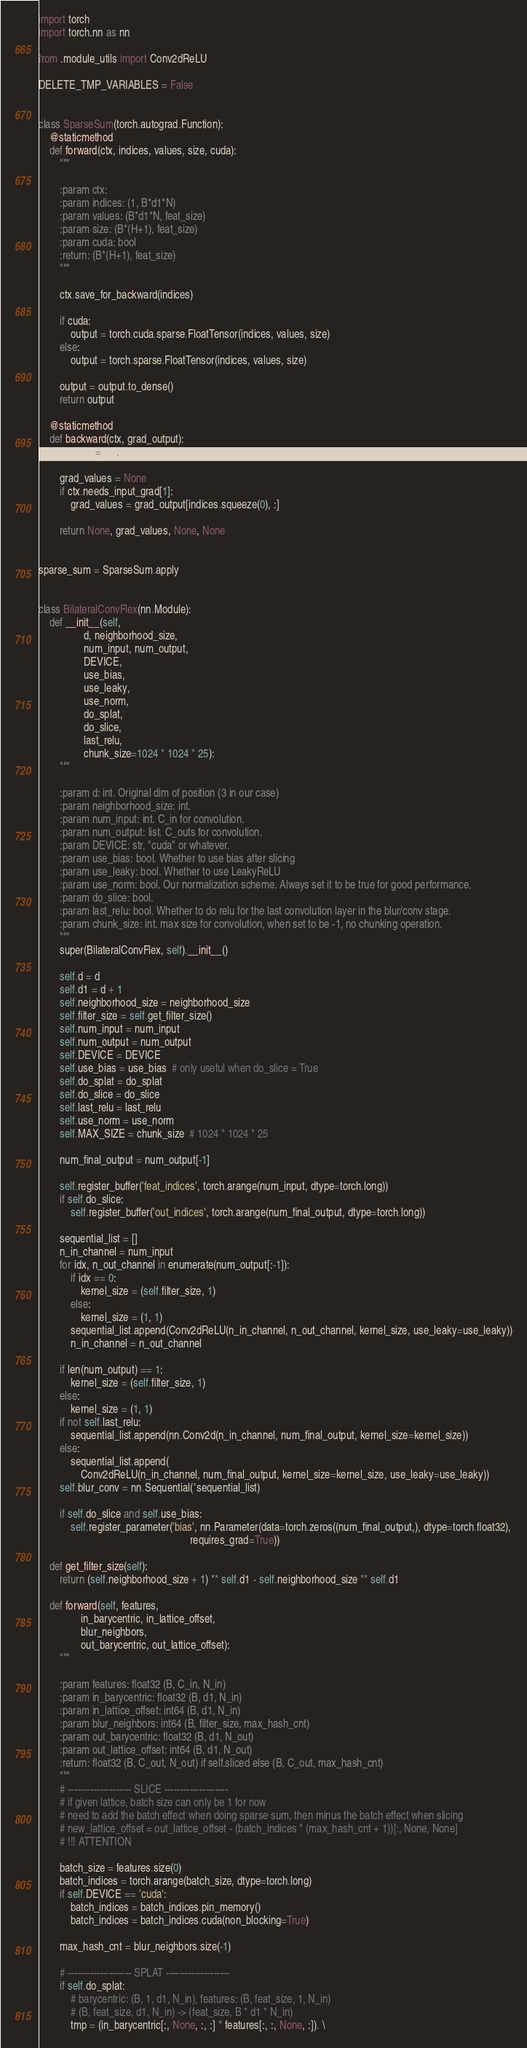Convert code to text. <code><loc_0><loc_0><loc_500><loc_500><_Python_>import torch
import torch.nn as nn

from .module_utils import Conv2dReLU

DELETE_TMP_VARIABLES = False


class SparseSum(torch.autograd.Function):
    @staticmethod
    def forward(ctx, indices, values, size, cuda):
        """

        :param ctx:
        :param indices: (1, B*d1*N)
        :param values: (B*d1*N, feat_size)
        :param size: (B*(H+1), feat_size)
        :param cuda: bool
        :return: (B*(H+1), feat_size)
        """

        ctx.save_for_backward(indices)

        if cuda:
            output = torch.cuda.sparse.FloatTensor(indices, values, size)
        else:
            output = torch.sparse.FloatTensor(indices, values, size)

        output = output.to_dense()
        return output

    @staticmethod
    def backward(ctx, grad_output):
        indices, = ctx.saved_tensors

        grad_values = None
        if ctx.needs_input_grad[1]:
            grad_values = grad_output[indices.squeeze(0), :]

        return None, grad_values, None, None


sparse_sum = SparseSum.apply


class BilateralConvFlex(nn.Module):
    def __init__(self,
                 d, neighborhood_size,
                 num_input, num_output,
                 DEVICE,
                 use_bias,
                 use_leaky,
                 use_norm,
                 do_splat,
                 do_slice,
                 last_relu,
                 chunk_size=1024 * 1024 * 25):
        """

        :param d: int. Original dim of position (3 in our case)
        :param neighborhood_size: int.
        :param num_input: int. C_in for convolution.
        :param num_output: list. C_outs for convolution.
        :param DEVICE: str, "cuda" or whatever.
        :param use_bias: bool. Whether to use bias after slicing
        :param use_leaky: bool. Whether to use LeakyReLU
        :param use_norm: bool. Our normalization scheme. Always set it to be true for good performance.
        :param do_slice: bool.
        :param last_relu: bool. Whether to do relu for the last convolution layer in the blur/conv stage.
        :param chunk_size: int. max size for convolution, when set to be -1, no chunking operation.
        """
        super(BilateralConvFlex, self).__init__()

        self.d = d
        self.d1 = d + 1
        self.neighborhood_size = neighborhood_size
        self.filter_size = self.get_filter_size()
        self.num_input = num_input
        self.num_output = num_output
        self.DEVICE = DEVICE
        self.use_bias = use_bias  # only useful when do_slice = True
        self.do_splat = do_splat
        self.do_slice = do_slice
        self.last_relu = last_relu
        self.use_norm = use_norm
        self.MAX_SIZE = chunk_size  # 1024 * 1024 * 25

        num_final_output = num_output[-1]

        self.register_buffer('feat_indices', torch.arange(num_input, dtype=torch.long))
        if self.do_slice:
            self.register_buffer('out_indices', torch.arange(num_final_output, dtype=torch.long))

        sequential_list = []
        n_in_channel = num_input
        for idx, n_out_channel in enumerate(num_output[:-1]):
            if idx == 0:
                kernel_size = (self.filter_size, 1)
            else:
                kernel_size = (1, 1)
            sequential_list.append(Conv2dReLU(n_in_channel, n_out_channel, kernel_size, use_leaky=use_leaky))
            n_in_channel = n_out_channel

        if len(num_output) == 1:
            kernel_size = (self.filter_size, 1)
        else:
            kernel_size = (1, 1)
        if not self.last_relu:
            sequential_list.append(nn.Conv2d(n_in_channel, num_final_output, kernel_size=kernel_size))
        else:
            sequential_list.append(
                Conv2dReLU(n_in_channel, num_final_output, kernel_size=kernel_size, use_leaky=use_leaky))
        self.blur_conv = nn.Sequential(*sequential_list)

        if self.do_slice and self.use_bias:
            self.register_parameter('bias', nn.Parameter(data=torch.zeros((num_final_output,), dtype=torch.float32),
                                                         requires_grad=True))

    def get_filter_size(self):
        return (self.neighborhood_size + 1) ** self.d1 - self.neighborhood_size ** self.d1

    def forward(self, features,
                in_barycentric, in_lattice_offset,
                blur_neighbors,
                out_barycentric, out_lattice_offset):
        """

        :param features: float32 (B, C_in, N_in)
        :param in_barycentric: float32 (B, d1, N_in)
        :param in_lattice_offset: int64 (B, d1, N_in)
        :param blur_neighbors: int64 (B, filter_size, max_hash_cnt)
        :param out_barycentric: float32 (B, d1, N_out)
        :param out_lattice_offset: int64 (B, d1, N_out)
        :return: float32 (B, C_out, N_out) if self.sliced else (B, C_out, max_hash_cnt)
        """
        # -------------------- SLICE --------------------
        # if given lattice, batch size can only be 1 for now
        # need to add the batch effect when doing sparse sum, then minus the batch effect when slicing
        # new_lattice_offset = out_lattice_offset - (batch_indices * (max_hash_cnt + 1))[:, None, None]
        # !!! ATTENTION

        batch_size = features.size(0)
        batch_indices = torch.arange(batch_size, dtype=torch.long)
        if self.DEVICE == 'cuda':
            batch_indices = batch_indices.pin_memory()
            batch_indices = batch_indices.cuda(non_blocking=True)

        max_hash_cnt = blur_neighbors.size(-1)

        # -------------------- SPLAT --------------------
        if self.do_splat:
            # barycentric: (B, 1, d1, N_in), features: (B, feat_size, 1, N_in)
            # (B, feat_size, d1, N_in) -> (feat_size, B * d1 * N_in)
            tmp = (in_barycentric[:, None, :, :] * features[:, :, None, :]). \</code> 